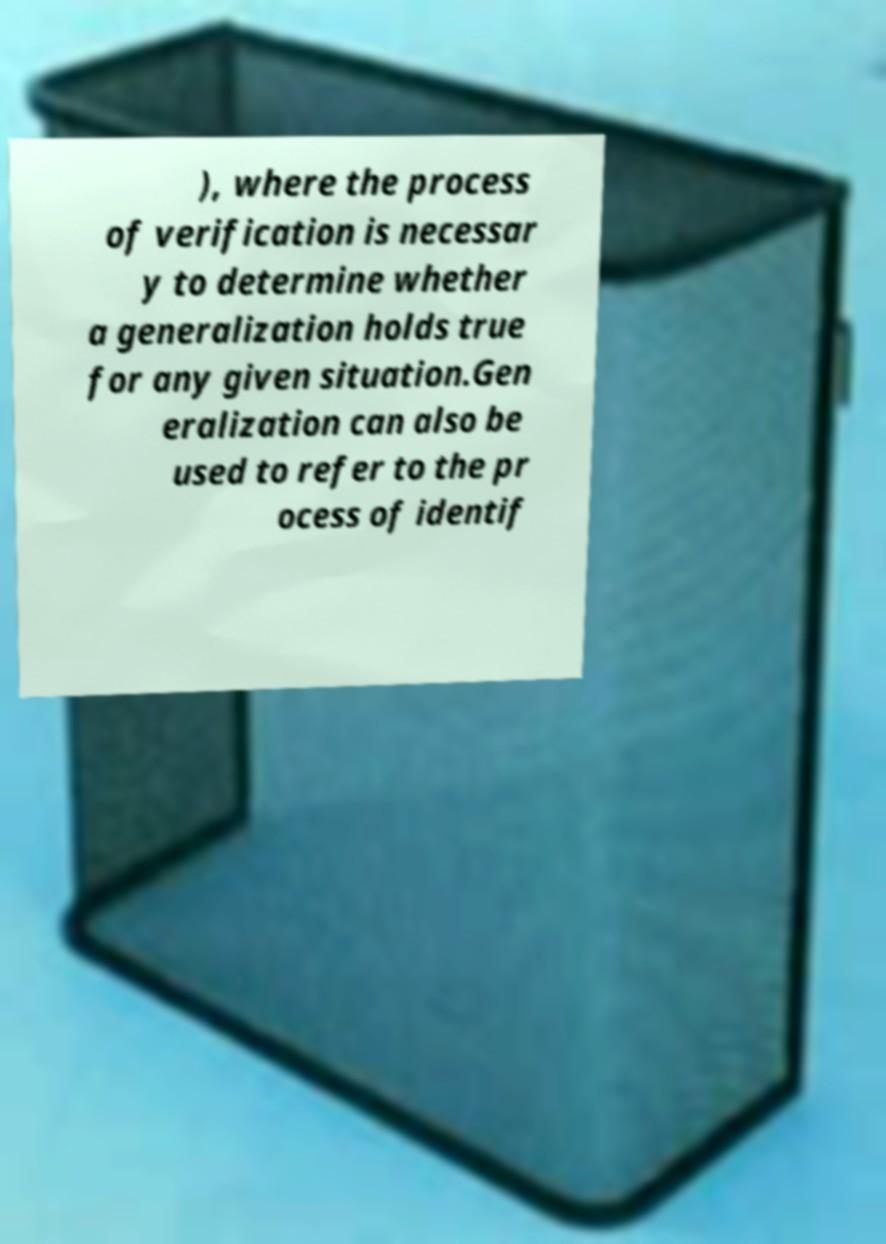Please identify and transcribe the text found in this image. ), where the process of verification is necessar y to determine whether a generalization holds true for any given situation.Gen eralization can also be used to refer to the pr ocess of identif 